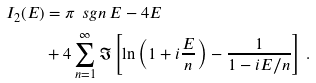<formula> <loc_0><loc_0><loc_500><loc_500>I _ { 2 } ( E ) & = \pi \, \ s g n \, E - 4 E \\ & + 4 \sum _ { n = 1 } ^ { \infty } \Im \left [ \ln \left ( 1 + i \frac { E } { n } \right ) - \frac { 1 } { 1 - i E / n } \right ] \, .</formula> 